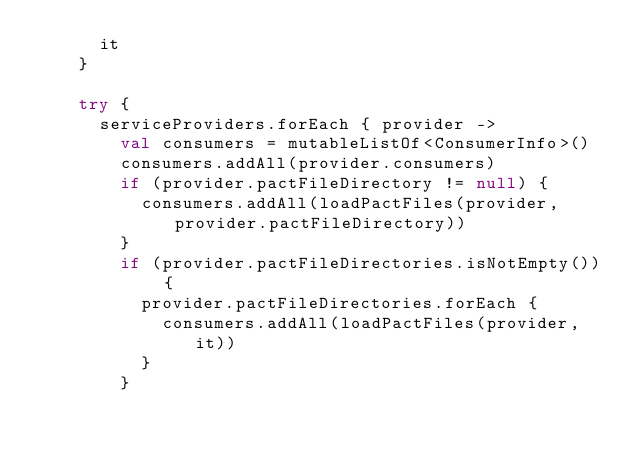Convert code to text. <code><loc_0><loc_0><loc_500><loc_500><_Kotlin_>      it
    }

    try {
      serviceProviders.forEach { provider ->
        val consumers = mutableListOf<ConsumerInfo>()
        consumers.addAll(provider.consumers)
        if (provider.pactFileDirectory != null) {
          consumers.addAll(loadPactFiles(provider, provider.pactFileDirectory))
        }
        if (provider.pactFileDirectories.isNotEmpty()) {
          provider.pactFileDirectories.forEach {
            consumers.addAll(loadPactFiles(provider, it))
          }
        }</code> 